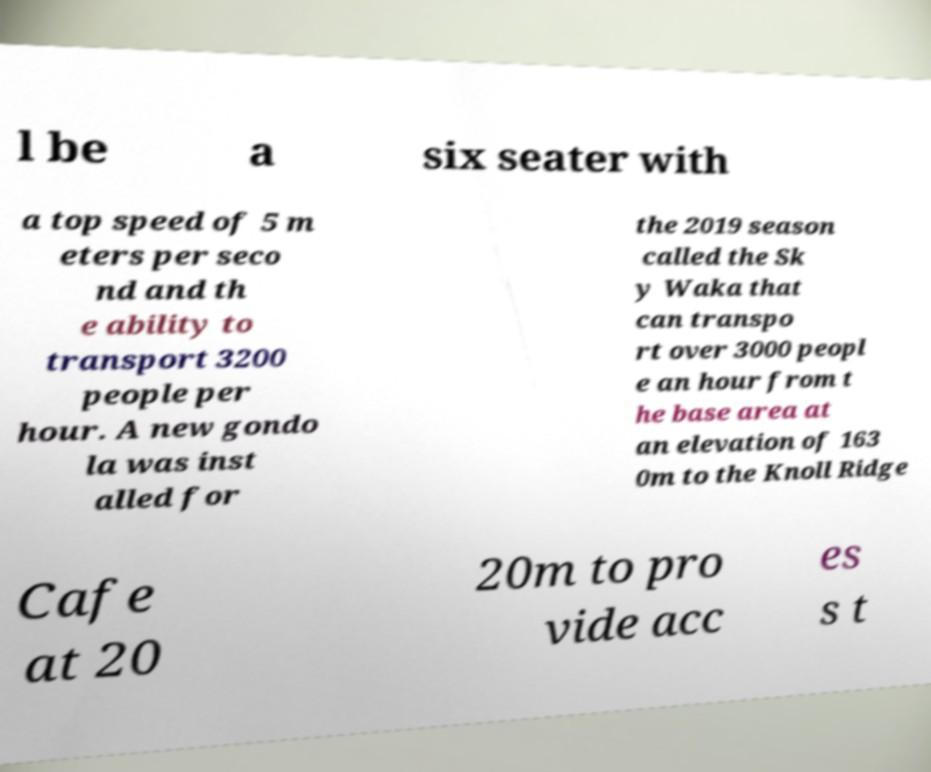Could you assist in decoding the text presented in this image and type it out clearly? l be a six seater with a top speed of 5 m eters per seco nd and th e ability to transport 3200 people per hour. A new gondo la was inst alled for the 2019 season called the Sk y Waka that can transpo rt over 3000 peopl e an hour from t he base area at an elevation of 163 0m to the Knoll Ridge Cafe at 20 20m to pro vide acc es s t 